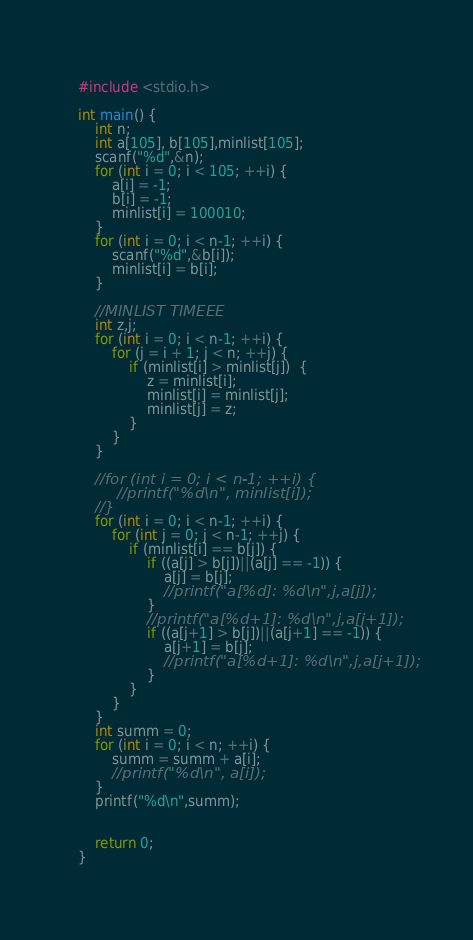<code> <loc_0><loc_0><loc_500><loc_500><_C_>#include <stdio.h>

int main() {
    int n;
    int a[105], b[105],minlist[105];
    scanf("%d",&n);
    for (int i = 0; i < 105; ++i) {
        a[i] = -1;
        b[i] = -1;
        minlist[i] = 100010;
    }
    for (int i = 0; i < n-1; ++i) {
        scanf("%d",&b[i]);
        minlist[i] = b[i];
    }

    //MINLIST TIMEEE
    int z,j;
    for (int i = 0; i < n-1; ++i) {
        for (j = i + 1; j < n; ++j) {
            if (minlist[i] > minlist[j])  {
                z = minlist[i];
                minlist[i] = minlist[j];
                minlist[j] = z;
            }
        }
    }

    //for (int i = 0; i < n-1; ++i) {
         //printf("%d\n", minlist[i]);
    //}
    for (int i = 0; i < n-1; ++i) {
        for (int j = 0; j < n-1; ++j) {
            if (minlist[i] == b[j]) {
                if ((a[j] > b[j])||(a[j] == -1)) {
                    a[j] = b[j];
                    //printf("a[%d]: %d\n",j,a[j]);
                }
                //printf("a[%d+1]: %d\n",j,a[j+1]);
                if ((a[j+1] > b[j])||(a[j+1] == -1)) {
                    a[j+1] = b[j];
                    //printf("a[%d+1]: %d\n",j,a[j+1]);
                }
            }
        }
    }
    int summ = 0;
    for (int i = 0; i < n; ++i) {
        summ = summ + a[i];
        //printf("%d\n", a[i]);
    }
    printf("%d\n",summ);


    return 0;
}
</code> 